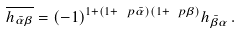<formula> <loc_0><loc_0><loc_500><loc_500>\overline { h _ { \bar { \alpha } \beta } } = ( - 1 ) ^ { 1 + ( 1 + \ p { \bar { \alpha } } ) ( 1 + \ p { \beta } ) } h _ { \bar { \beta } \alpha } \, .</formula> 